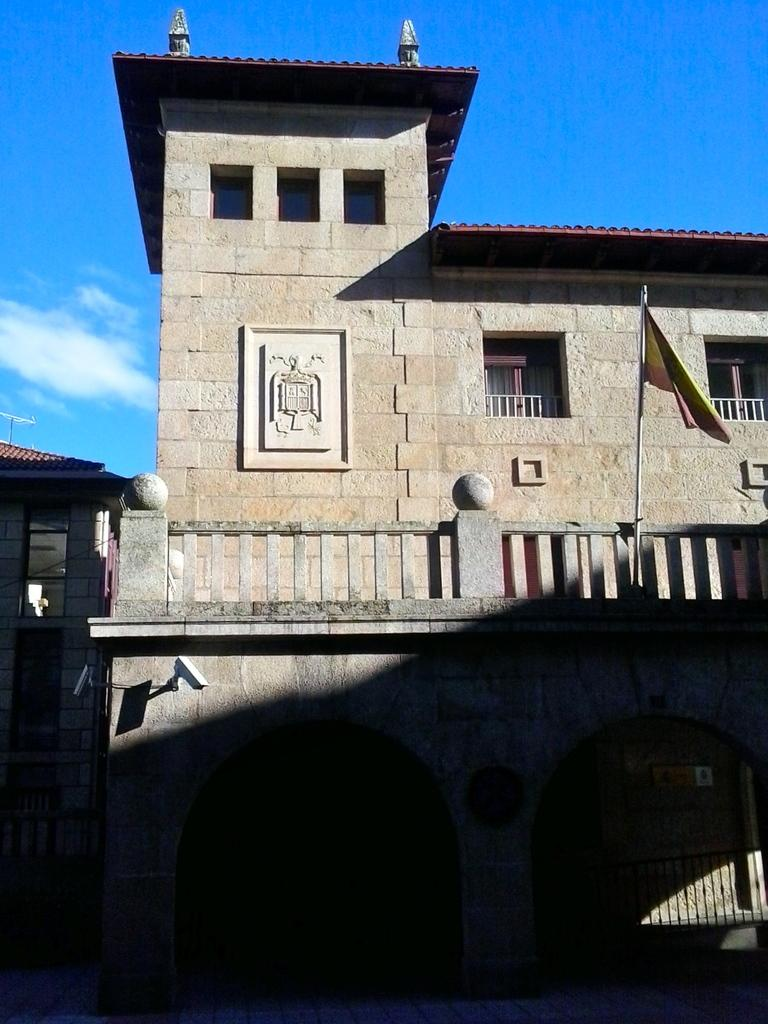What type of structures are visible in the image? There are buildings in the image. How would you describe the sky in the image? The sky is cloudy in the image. Can you identify any specific features related to the buildings? There is a flag in front of a building, and the building with the flag is in the center of the image. Is there a woman walking up the steps of the building with the flag in the image? There is no woman or steps visible in the image; it only shows buildings and a flag. 